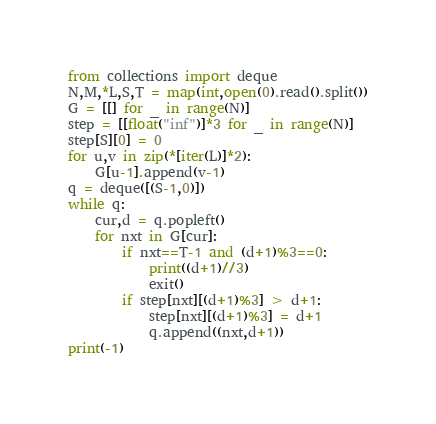Convert code to text. <code><loc_0><loc_0><loc_500><loc_500><_Python_>from collections import deque
N,M,*L,S,T = map(int,open(0).read().split())
G = [[] for _ in range(N)]
step = [[float("inf")]*3 for _ in range(N)]
step[S][0] = 0
for u,v in zip(*[iter(L)]*2):
	G[u-1].append(v-1)
q = deque([(S-1,0)])
while q:
	cur,d = q.popleft()
	for nxt in G[cur]:
		if nxt==T-1 and (d+1)%3==0:
			print((d+1)//3)
			exit()
		if step[nxt][(d+1)%3] > d+1:
			step[nxt][(d+1)%3] = d+1
			q.append((nxt,d+1))
print(-1)</code> 